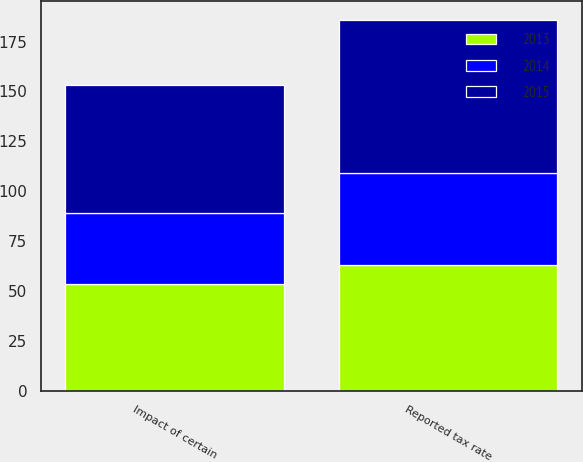<chart> <loc_0><loc_0><loc_500><loc_500><stacked_bar_chart><ecel><fcel>Reported tax rate<fcel>Impact of certain<nl><fcel>2013<fcel>63.2<fcel>53.5<nl><fcel>2015<fcel>76.7<fcel>64.5<nl><fcel>2014<fcel>46<fcel>35.4<nl></chart> 